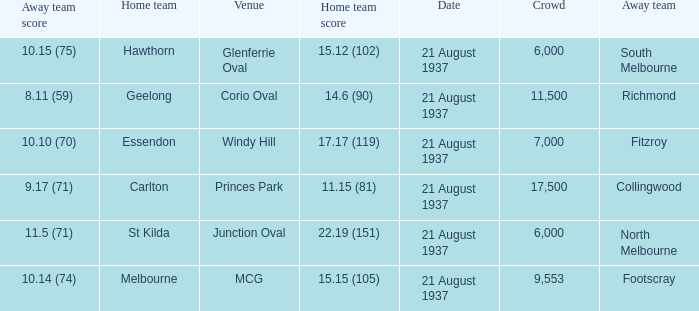Where did Richmond play? Corio Oval. 